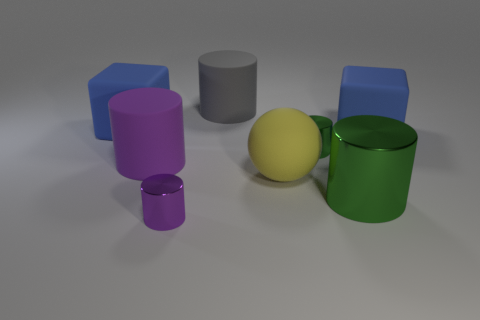What is the size of the cylinder that is the same color as the big metal object?
Give a very brief answer. Small. There is a big purple rubber thing to the left of the purple metallic object; what is its shape?
Offer a terse response. Cylinder. How many things are left of the rubber cylinder behind the big rubber block that is to the right of the big gray thing?
Your answer should be compact. 3. Does the rubber ball have the same size as the blue rubber object right of the small purple metallic cylinder?
Keep it short and to the point. Yes. How big is the matte block behind the large block that is on the right side of the large metallic object?
Give a very brief answer. Large. How many tiny cylinders have the same material as the big ball?
Ensure brevity in your answer.  0. Is there a tiny purple metallic cube?
Provide a succinct answer. No. There is a metallic cylinder that is on the left side of the tiny green cylinder; how big is it?
Your answer should be very brief. Small. How many other cylinders have the same color as the large metal cylinder?
Offer a terse response. 1. What number of spheres are tiny metal things or gray things?
Ensure brevity in your answer.  0. 